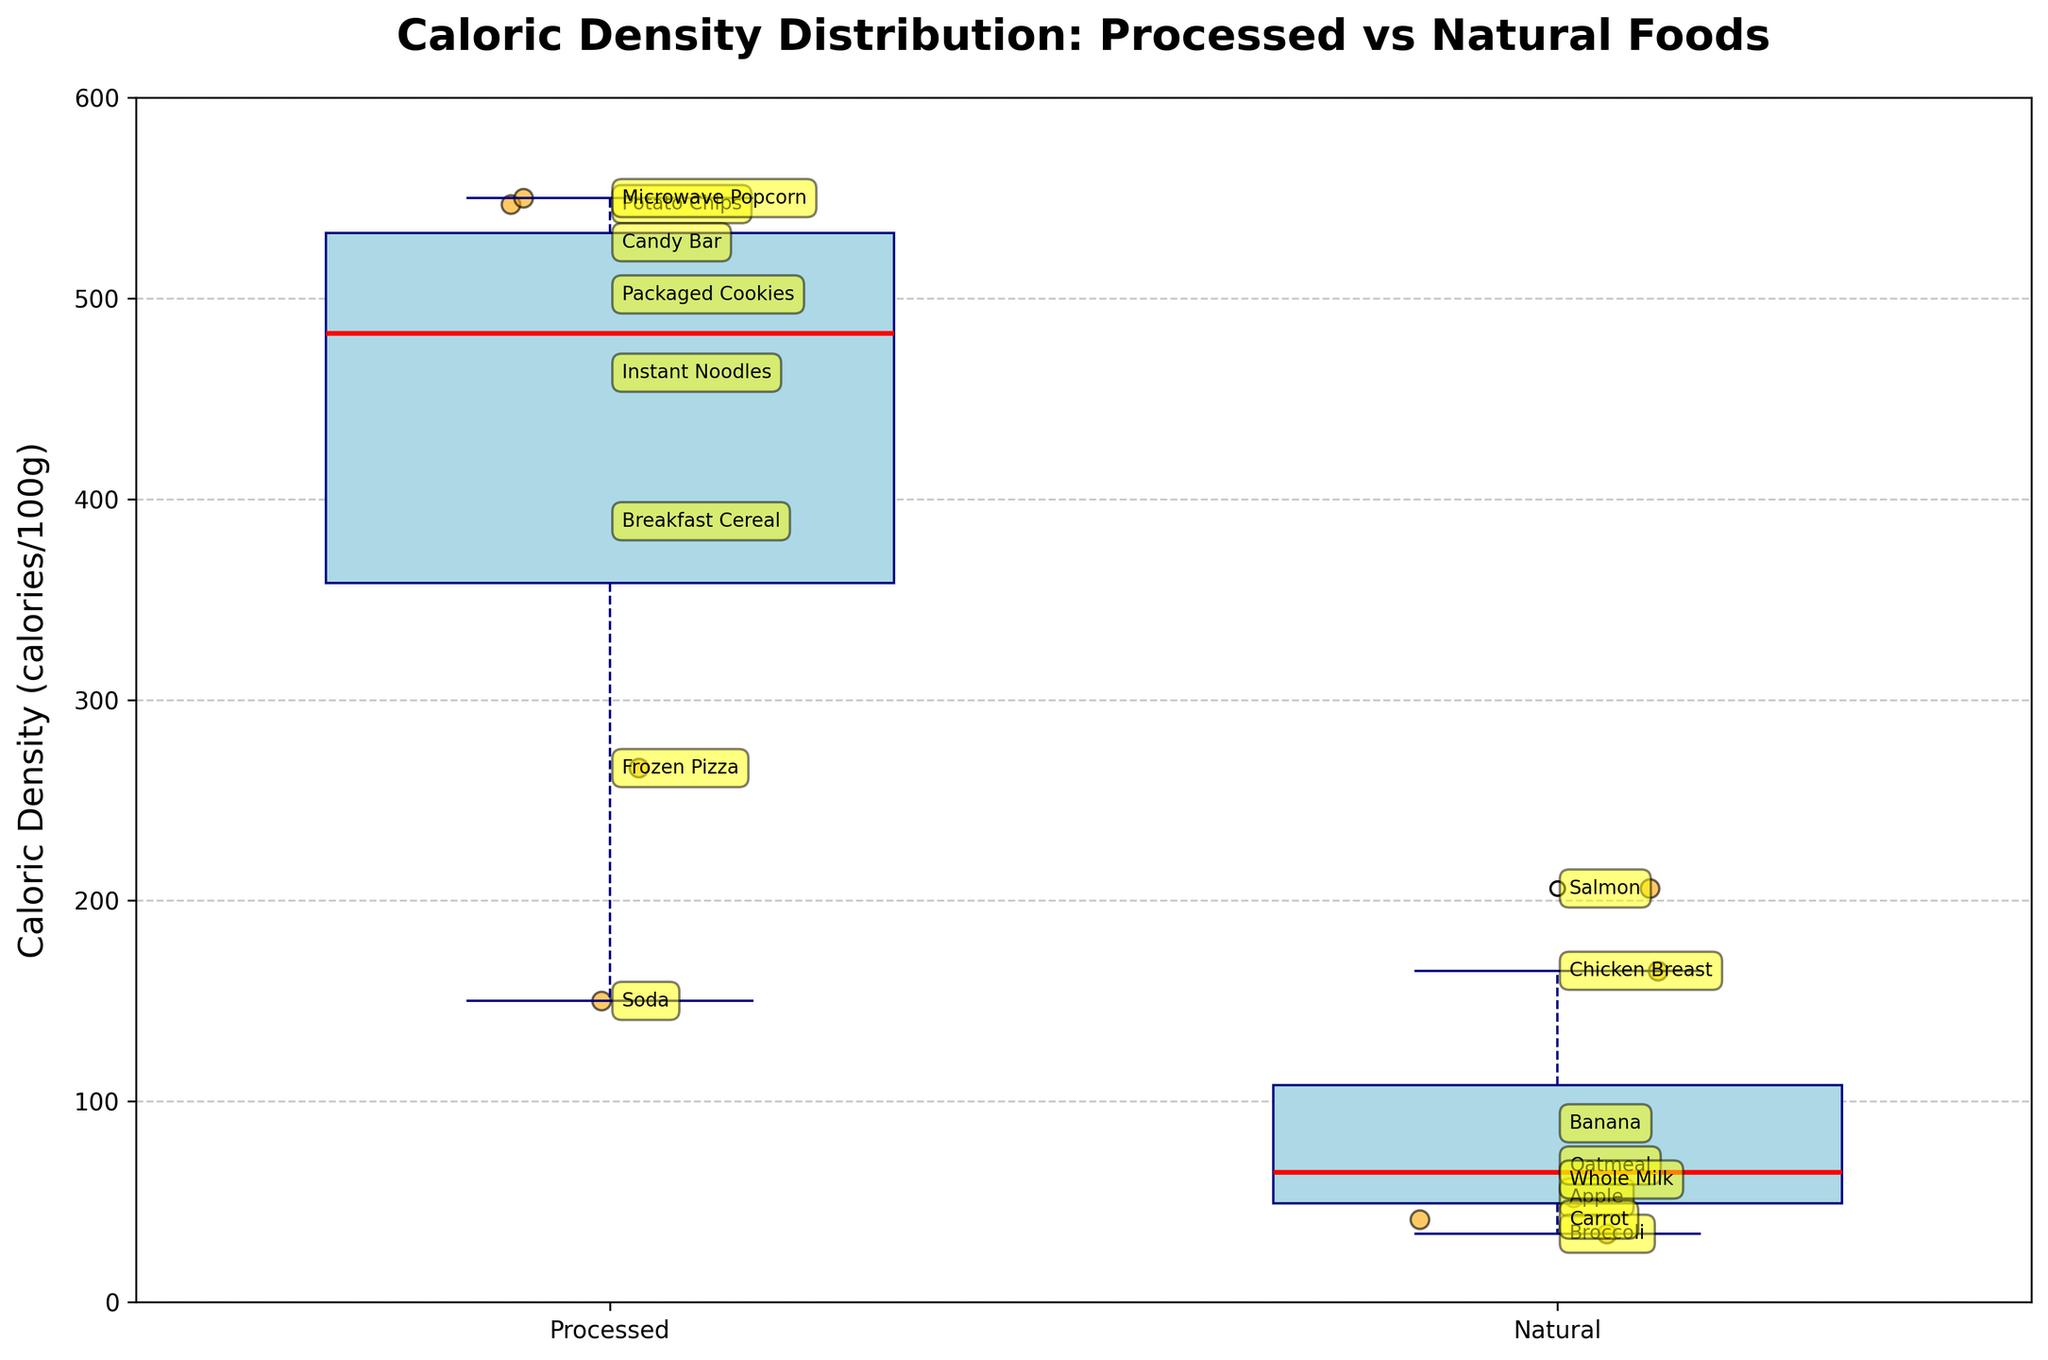How many processed and natural food items are plotted? Count the scatter points for each group in the figure. There are 8 scatter points for processed foods and 8 scatter points for natural foods.
Answer: 8 processed, 8 natural What's the title of the figure? Read the title at the top of the plot. The title is "Caloric Density Distribution: Processed vs Natural Foods."
Answer: Caloric Density Distribution: Processed vs Natural Foods Which processed food item has the highest caloric density? Identify the scatter point with the highest value for the processed foods and refer to the food item label. The highest caloric density is 550, which corresponds to Microwave Popcorn.
Answer: Microwave Popcorn What's the median caloric density of natural foods? Look at the line inside the box for natural foods. The median line is around 68.
Answer: 68 How does the caloric density of potato chips compare to that of apples? Locate the caloric density for both potato chips (547) and apples (52) on the y-axis and compare them. Potato chips have a much higher caloric density than apples.
Answer: Potato chips > apples Which category has more variation in caloric density? Compare the height of the boxes and the spread of the scatter points for both categories. Processed foods show a larger box and a wider spread of points, indicating more variation.
Answer: Processed What's the average caloric density of processed foods? Add the caloric densities for processed foods and divide by the number of items: (547 + 266 + 389 + 463 + 528 + 550 + 502 + 150) / 8 = 339.375.
Answer: 339.375 Are there any foods with caloric density significantly below 100 calories/100g? Identify any scatter points with a caloric density below 100. Natural foods including apple (52), banana (89), broccoli (34), carrot (41), and whole milk (61) fall below this threshold.
Answer: Yes, apples, bananas, broccoli, carrots, whole milk What is the interquartile range (IQR) for processed foods? Identify the bottom and top of the box for processed foods. The IQR is the range between the first quartile (Q1) and the third quartile (Q3). For processed foods, Q1 is approximately 292, and Q3 is approximately 507. Therefore, IQR = 507 - 292 = 215.
Answer: 215 Based on the figure, do natural foods generally have a higher or lower caloric density compared to processed foods? Compare the overall height and position of the boxes for both categories. Natural foods generally have lower caloric densities compared to processed foods.
Answer: Lower 